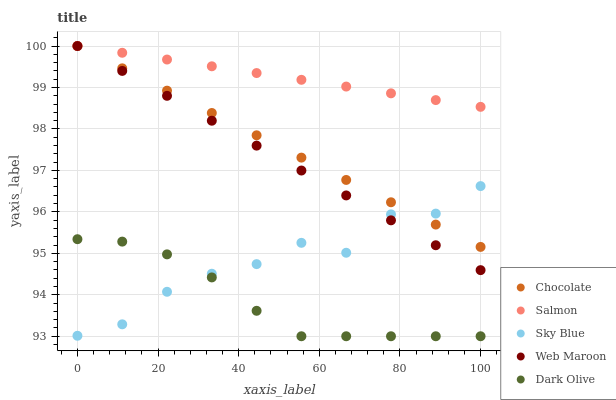Does Dark Olive have the minimum area under the curve?
Answer yes or no. Yes. Does Salmon have the maximum area under the curve?
Answer yes or no. Yes. Does Salmon have the minimum area under the curve?
Answer yes or no. No. Does Dark Olive have the maximum area under the curve?
Answer yes or no. No. Is Chocolate the smoothest?
Answer yes or no. Yes. Is Sky Blue the roughest?
Answer yes or no. Yes. Is Dark Olive the smoothest?
Answer yes or no. No. Is Dark Olive the roughest?
Answer yes or no. No. Does Dark Olive have the lowest value?
Answer yes or no. Yes. Does Salmon have the lowest value?
Answer yes or no. No. Does Chocolate have the highest value?
Answer yes or no. Yes. Does Dark Olive have the highest value?
Answer yes or no. No. Is Dark Olive less than Chocolate?
Answer yes or no. Yes. Is Chocolate greater than Dark Olive?
Answer yes or no. Yes. Does Chocolate intersect Sky Blue?
Answer yes or no. Yes. Is Chocolate less than Sky Blue?
Answer yes or no. No. Is Chocolate greater than Sky Blue?
Answer yes or no. No. Does Dark Olive intersect Chocolate?
Answer yes or no. No. 